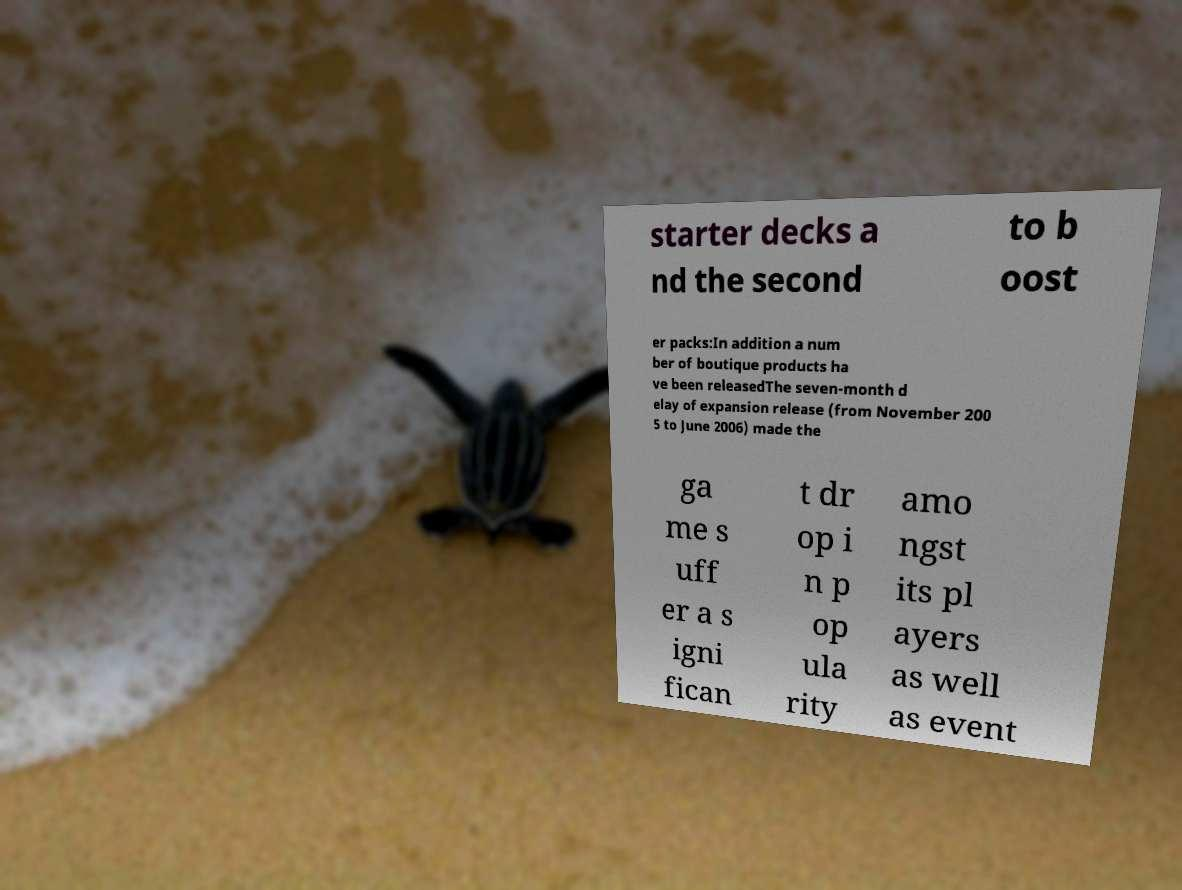What messages or text are displayed in this image? I need them in a readable, typed format. starter decks a nd the second to b oost er packs:In addition a num ber of boutique products ha ve been releasedThe seven-month d elay of expansion release (from November 200 5 to June 2006) made the ga me s uff er a s igni fican t dr op i n p op ula rity amo ngst its pl ayers as well as event 